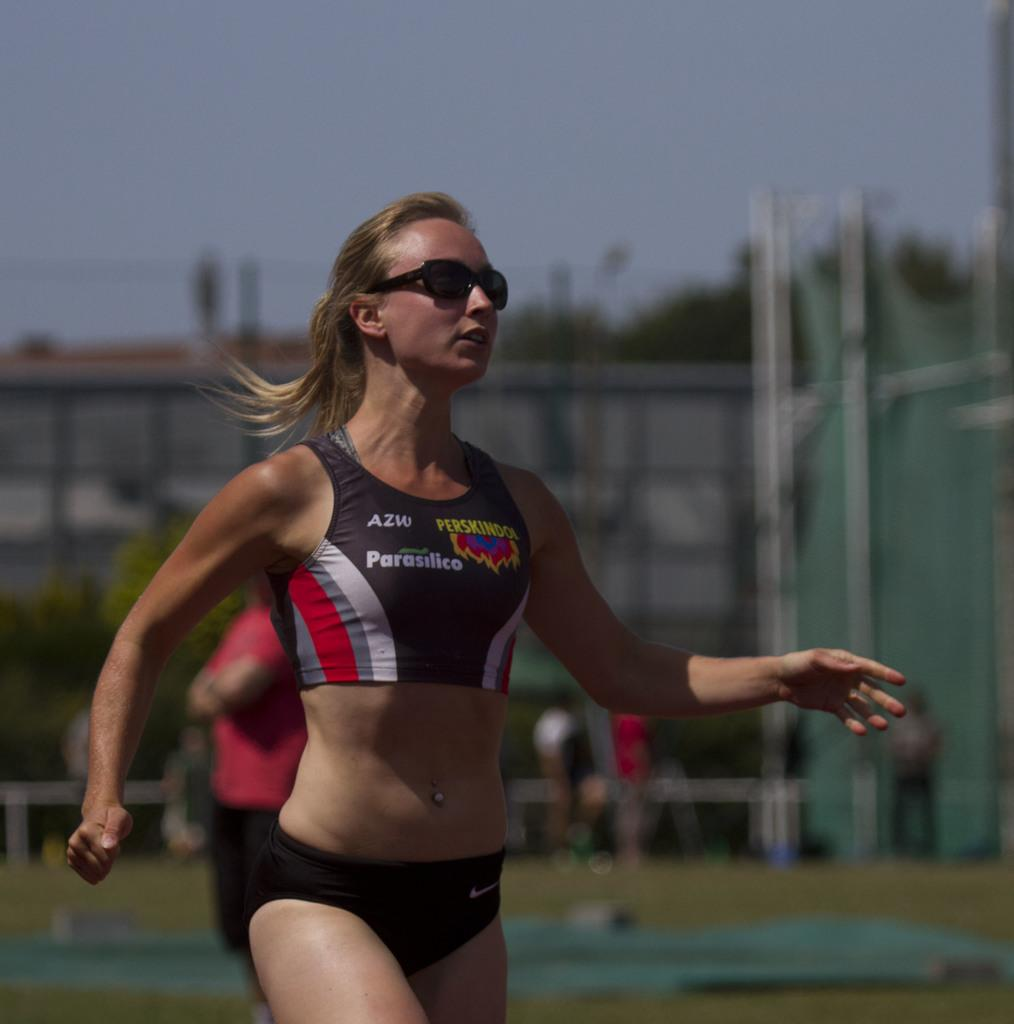<image>
Write a terse but informative summary of the picture. A woman wearing sunglasses and an AZW, Parasilico, and Perskindol branded athletic top enjoys an outdoor activity. 